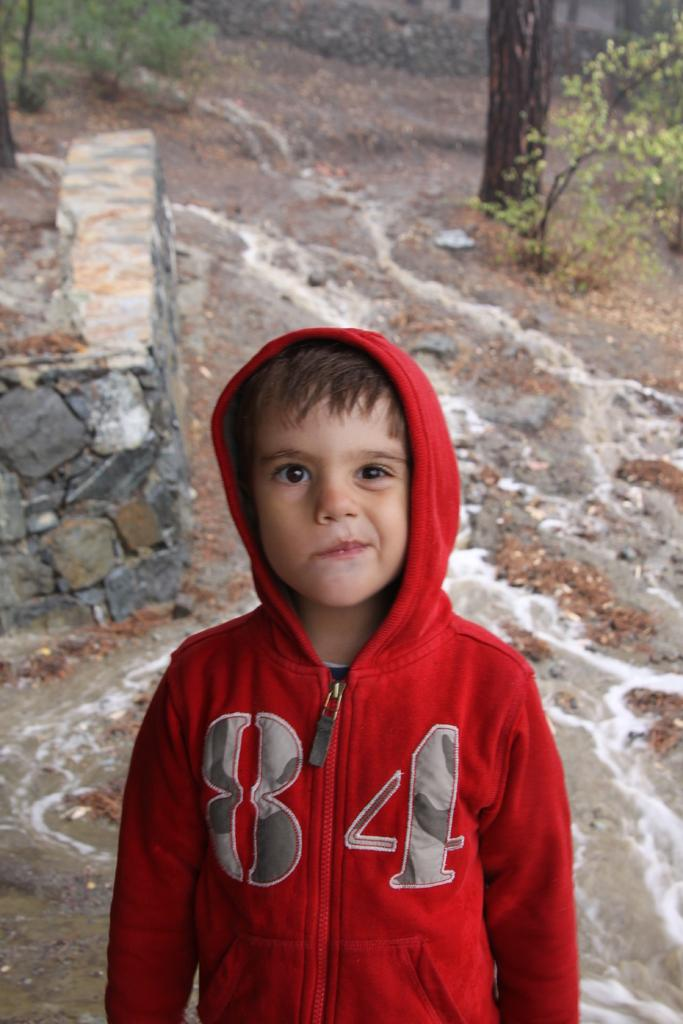Who is present in the image? There is a boy in the image. What is the boy doing in the image? The boy is standing in the image. What is the boy wearing in the image? The boy is wearing a red color hoodie in the image. What can be seen in the background of the image? There is a tree and plants in the background of the image. What type of knowledge can be seen in the boy's hands in the image? There is no knowledge visible in the boy's hands in the image. What mark does the boy have on his forehead in the image? There is no mark visible on the boy's forehead in the image. 